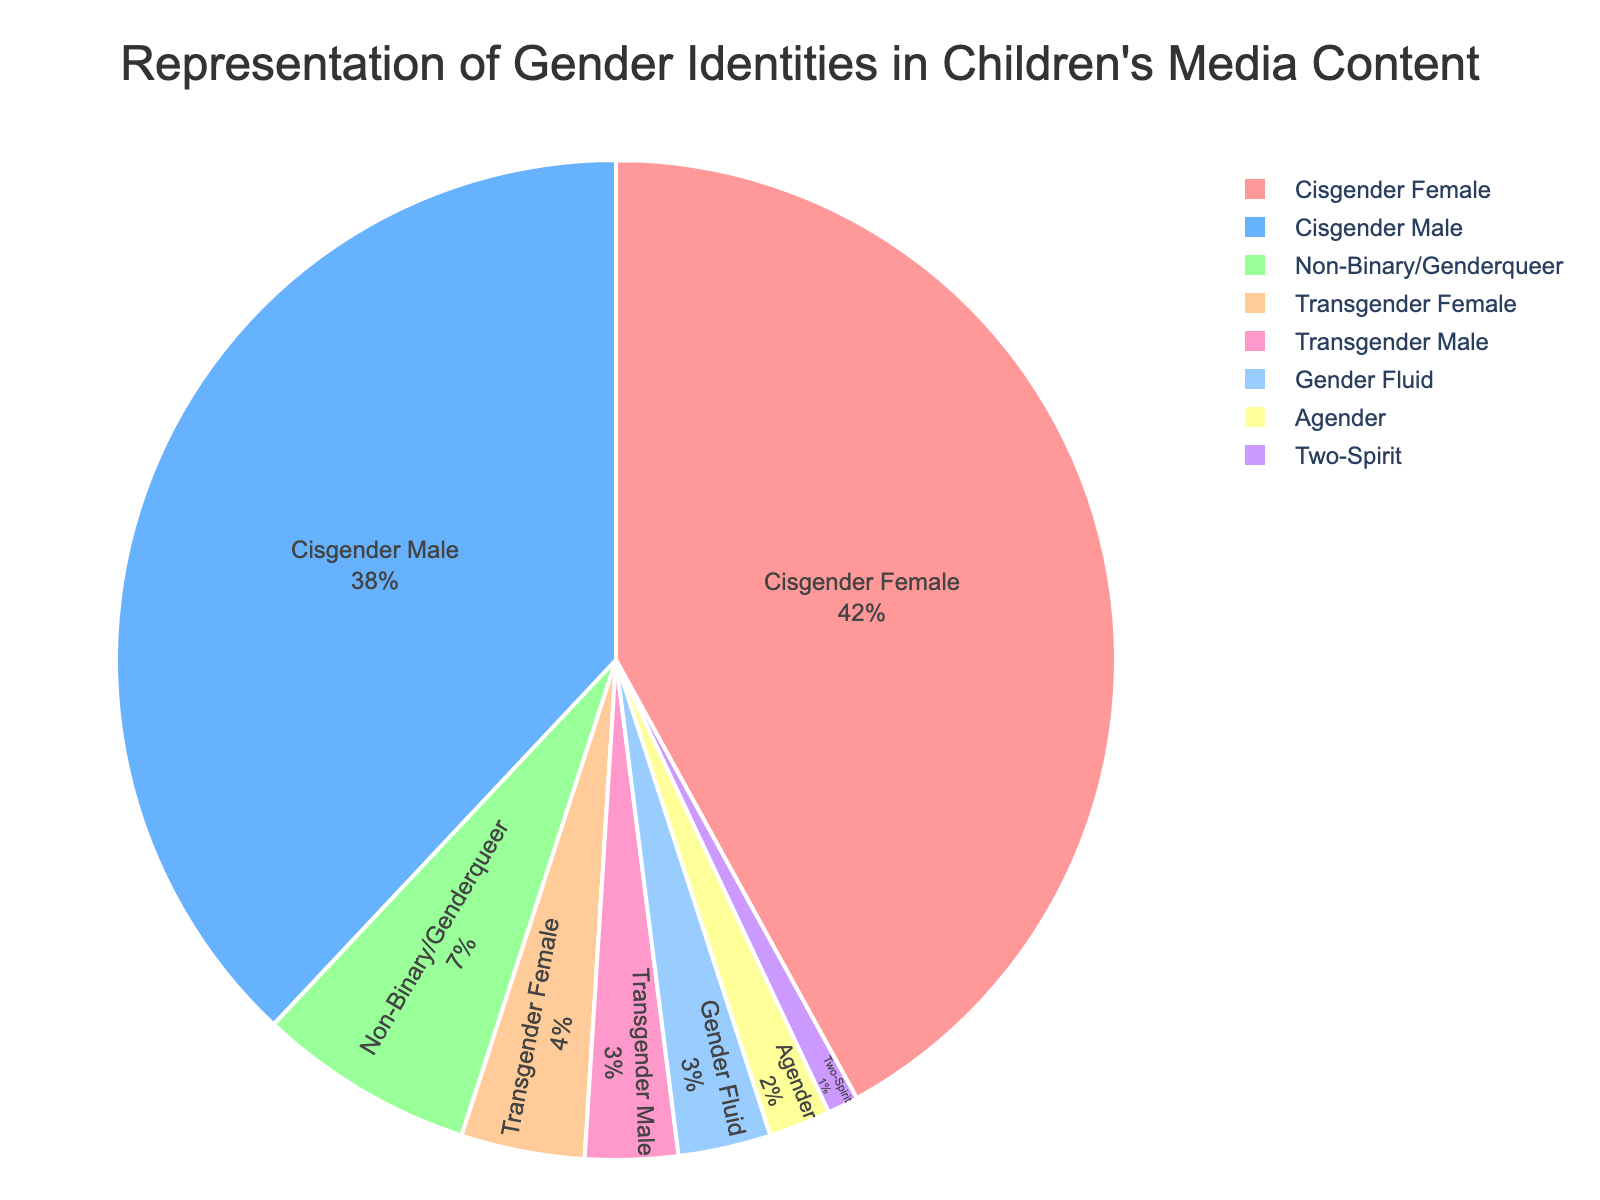What percentage of the depicted gender identities fall under non-cisgender categories? To determine the percentage of non-cisgender identities, sum the percentages of Non-Binary/Genderqueer, Transgender Female, Transgender Male, Gender Fluid, Agender, and Two-Spirit: 7% + 4% + 3% + 3% + 2% + 1% = 20%.
Answer: 20% Which gender identity has the smallest representation? The smallest representation is indicated by the segment with the lowest percentage. Two-Spirit is represented by 1%, which is the smallest percentage in the pie chart.
Answer: Two-Spirit Are cisgender identities more frequently represented than all non-cisgender identities combined? Add the percentages of Cisgender Female and Cisgender Male: 42% + 38% = 80%. Compare this with the combined non-cisgender representation: 20%. As 80% is greater than 20%, cisgender identities are more frequently represented.
Answer: Yes Which three gender identities have the highest representation in the chart? The three identities with the highest percentages in the chart are visible as: Cisgender Female (42%), Cisgender Male (38%), and Non-Binary/Genderqueer (7%).
Answer: Cisgender Female, Cisgender Male, Non-Binary/Genderqueer What is the difference in representation between Cisgender Female and Transgender Male? Subtract the percentage of Transgender Male (3%) from the percentage of Cisgender Female (42%): 42% - 3% = 39%.
Answer: 39% How do the combined percentages of Gender Fluid and Agender compare with the percentage of Non-Binary/Genderqueer? First, sum the percentages of Gender Fluid and Agender: 3% + 2% = 5%. Then compare this with the percentage of Non-Binary/Genderqueer (7%). Since 5% is less than 7%, the combined percentage of Gender Fluid and Agender is smaller.
Answer: Less Which section of the pie chart is represented by the color corresponding to Cisgender Male? In the visual chart, the section corresponding to Cisgender Male is represented by the second listed color, which is a shade of blue as per the custom color palette.
Answer: Blue What is the total percentage representation of Transgender Female, Transgender Male, and Gender Fluid combined? Add the percentages of Transgender Female (4%), Transgender Male (3%), and Gender Fluid (3%): 4% + 3% + 3% = 10%.
Answer: 10% Is the slice representing Non-Binary/Genderqueer larger or smaller than the slice for Agender? By visually comparing the sizes of the segments, the Non-Binary/Genderqueer slice, which is 7%, is larger than the Agender slice, which is 2%.
Answer: Larger 